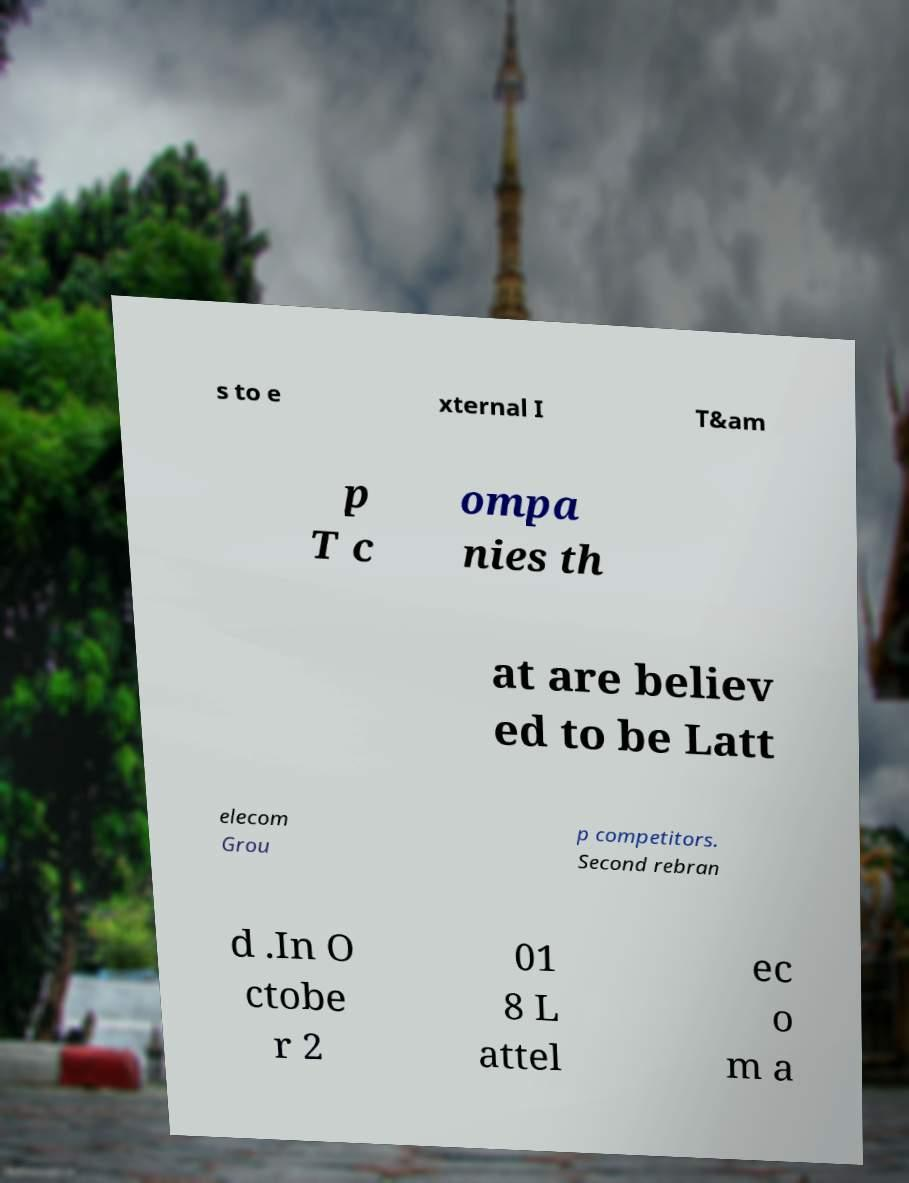What messages or text are displayed in this image? I need them in a readable, typed format. s to e xternal I T&am p T c ompa nies th at are believ ed to be Latt elecom Grou p competitors. Second rebran d .In O ctobe r 2 01 8 L attel ec o m a 